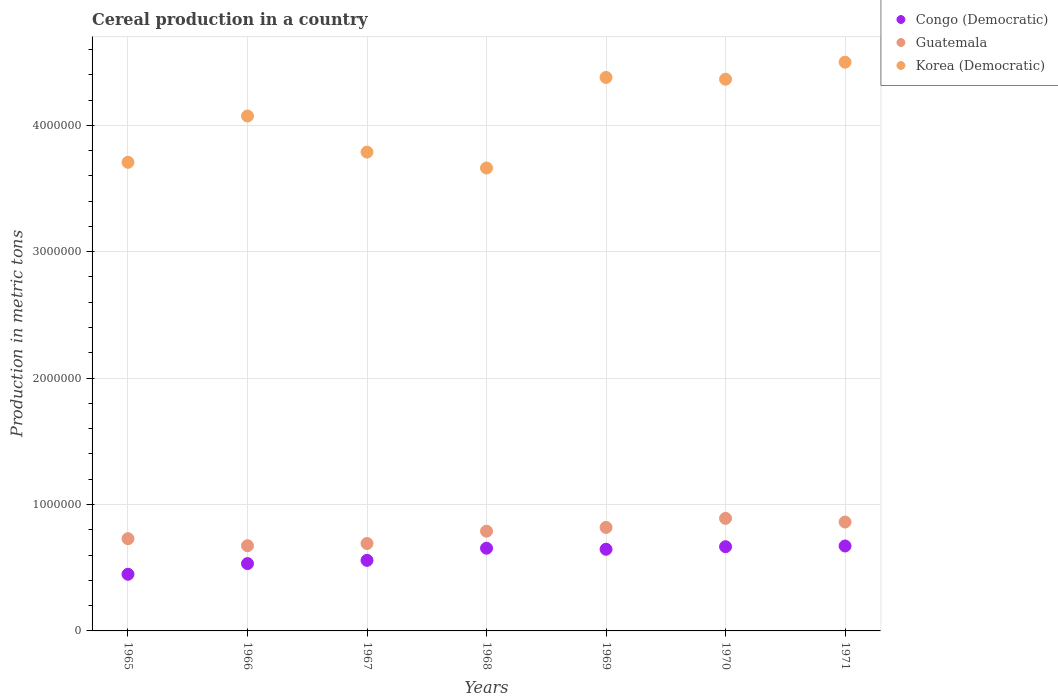How many different coloured dotlines are there?
Your response must be concise. 3. Is the number of dotlines equal to the number of legend labels?
Give a very brief answer. Yes. What is the total cereal production in Guatemala in 1967?
Provide a succinct answer. 6.92e+05. Across all years, what is the maximum total cereal production in Congo (Democratic)?
Provide a short and direct response. 6.72e+05. Across all years, what is the minimum total cereal production in Congo (Democratic)?
Provide a succinct answer. 4.48e+05. In which year was the total cereal production in Korea (Democratic) minimum?
Your answer should be very brief. 1968. What is the total total cereal production in Guatemala in the graph?
Provide a short and direct response. 5.46e+06. What is the difference between the total cereal production in Guatemala in 1965 and that in 1969?
Provide a succinct answer. -8.91e+04. What is the difference between the total cereal production in Guatemala in 1968 and the total cereal production in Congo (Democratic) in 1965?
Give a very brief answer. 3.41e+05. What is the average total cereal production in Korea (Democratic) per year?
Keep it short and to the point. 4.07e+06. In the year 1971, what is the difference between the total cereal production in Korea (Democratic) and total cereal production in Congo (Democratic)?
Your answer should be very brief. 3.83e+06. In how many years, is the total cereal production in Congo (Democratic) greater than 200000 metric tons?
Ensure brevity in your answer.  7. What is the ratio of the total cereal production in Guatemala in 1969 to that in 1970?
Provide a succinct answer. 0.92. What is the difference between the highest and the second highest total cereal production in Congo (Democratic)?
Your answer should be compact. 5769. What is the difference between the highest and the lowest total cereal production in Congo (Democratic)?
Your answer should be very brief. 2.24e+05. In how many years, is the total cereal production in Guatemala greater than the average total cereal production in Guatemala taken over all years?
Provide a short and direct response. 4. Is the sum of the total cereal production in Guatemala in 1967 and 1970 greater than the maximum total cereal production in Korea (Democratic) across all years?
Keep it short and to the point. No. Is the total cereal production in Korea (Democratic) strictly greater than the total cereal production in Guatemala over the years?
Your response must be concise. Yes. How many years are there in the graph?
Ensure brevity in your answer.  7. What is the difference between two consecutive major ticks on the Y-axis?
Provide a succinct answer. 1.00e+06. Does the graph contain any zero values?
Offer a terse response. No. Does the graph contain grids?
Make the answer very short. Yes. What is the title of the graph?
Give a very brief answer. Cereal production in a country. Does "Nepal" appear as one of the legend labels in the graph?
Your answer should be very brief. No. What is the label or title of the Y-axis?
Make the answer very short. Production in metric tons. What is the Production in metric tons of Congo (Democratic) in 1965?
Make the answer very short. 4.48e+05. What is the Production in metric tons of Guatemala in 1965?
Offer a terse response. 7.30e+05. What is the Production in metric tons of Korea (Democratic) in 1965?
Provide a short and direct response. 3.71e+06. What is the Production in metric tons in Congo (Democratic) in 1966?
Provide a succinct answer. 5.33e+05. What is the Production in metric tons in Guatemala in 1966?
Your answer should be compact. 6.74e+05. What is the Production in metric tons of Korea (Democratic) in 1966?
Give a very brief answer. 4.07e+06. What is the Production in metric tons of Congo (Democratic) in 1967?
Your answer should be very brief. 5.58e+05. What is the Production in metric tons in Guatemala in 1967?
Your answer should be compact. 6.92e+05. What is the Production in metric tons in Korea (Democratic) in 1967?
Offer a terse response. 3.79e+06. What is the Production in metric tons in Congo (Democratic) in 1968?
Your answer should be very brief. 6.54e+05. What is the Production in metric tons in Guatemala in 1968?
Provide a short and direct response. 7.89e+05. What is the Production in metric tons of Korea (Democratic) in 1968?
Offer a terse response. 3.66e+06. What is the Production in metric tons in Congo (Democratic) in 1969?
Your response must be concise. 6.46e+05. What is the Production in metric tons in Guatemala in 1969?
Your answer should be very brief. 8.19e+05. What is the Production in metric tons in Korea (Democratic) in 1969?
Offer a very short reply. 4.38e+06. What is the Production in metric tons of Congo (Democratic) in 1970?
Offer a terse response. 6.66e+05. What is the Production in metric tons in Guatemala in 1970?
Provide a short and direct response. 8.90e+05. What is the Production in metric tons in Korea (Democratic) in 1970?
Provide a short and direct response. 4.36e+06. What is the Production in metric tons of Congo (Democratic) in 1971?
Give a very brief answer. 6.72e+05. What is the Production in metric tons in Guatemala in 1971?
Provide a succinct answer. 8.61e+05. What is the Production in metric tons in Korea (Democratic) in 1971?
Provide a succinct answer. 4.50e+06. Across all years, what is the maximum Production in metric tons in Congo (Democratic)?
Provide a short and direct response. 6.72e+05. Across all years, what is the maximum Production in metric tons in Guatemala?
Your answer should be compact. 8.90e+05. Across all years, what is the maximum Production in metric tons of Korea (Democratic)?
Provide a short and direct response. 4.50e+06. Across all years, what is the minimum Production in metric tons in Congo (Democratic)?
Provide a succinct answer. 4.48e+05. Across all years, what is the minimum Production in metric tons of Guatemala?
Offer a very short reply. 6.74e+05. Across all years, what is the minimum Production in metric tons of Korea (Democratic)?
Offer a terse response. 3.66e+06. What is the total Production in metric tons in Congo (Democratic) in the graph?
Provide a succinct answer. 4.18e+06. What is the total Production in metric tons in Guatemala in the graph?
Keep it short and to the point. 5.46e+06. What is the total Production in metric tons of Korea (Democratic) in the graph?
Ensure brevity in your answer.  2.85e+07. What is the difference between the Production in metric tons in Congo (Democratic) in 1965 and that in 1966?
Keep it short and to the point. -8.44e+04. What is the difference between the Production in metric tons of Guatemala in 1965 and that in 1966?
Provide a succinct answer. 5.56e+04. What is the difference between the Production in metric tons of Korea (Democratic) in 1965 and that in 1966?
Your answer should be compact. -3.66e+05. What is the difference between the Production in metric tons in Congo (Democratic) in 1965 and that in 1967?
Provide a succinct answer. -1.10e+05. What is the difference between the Production in metric tons in Guatemala in 1965 and that in 1967?
Offer a terse response. 3.80e+04. What is the difference between the Production in metric tons of Korea (Democratic) in 1965 and that in 1967?
Ensure brevity in your answer.  -8.08e+04. What is the difference between the Production in metric tons of Congo (Democratic) in 1965 and that in 1968?
Keep it short and to the point. -2.06e+05. What is the difference between the Production in metric tons of Guatemala in 1965 and that in 1968?
Give a very brief answer. -5.94e+04. What is the difference between the Production in metric tons in Korea (Democratic) in 1965 and that in 1968?
Your answer should be very brief. 4.50e+04. What is the difference between the Production in metric tons of Congo (Democratic) in 1965 and that in 1969?
Offer a terse response. -1.98e+05. What is the difference between the Production in metric tons in Guatemala in 1965 and that in 1969?
Give a very brief answer. -8.91e+04. What is the difference between the Production in metric tons in Korea (Democratic) in 1965 and that in 1969?
Make the answer very short. -6.71e+05. What is the difference between the Production in metric tons of Congo (Democratic) in 1965 and that in 1970?
Offer a very short reply. -2.18e+05. What is the difference between the Production in metric tons in Guatemala in 1965 and that in 1970?
Your answer should be compact. -1.61e+05. What is the difference between the Production in metric tons in Korea (Democratic) in 1965 and that in 1970?
Offer a very short reply. -6.58e+05. What is the difference between the Production in metric tons in Congo (Democratic) in 1965 and that in 1971?
Make the answer very short. -2.24e+05. What is the difference between the Production in metric tons in Guatemala in 1965 and that in 1971?
Ensure brevity in your answer.  -1.32e+05. What is the difference between the Production in metric tons of Korea (Democratic) in 1965 and that in 1971?
Your answer should be compact. -7.92e+05. What is the difference between the Production in metric tons of Congo (Democratic) in 1966 and that in 1967?
Ensure brevity in your answer.  -2.56e+04. What is the difference between the Production in metric tons in Guatemala in 1966 and that in 1967?
Make the answer very short. -1.76e+04. What is the difference between the Production in metric tons of Korea (Democratic) in 1966 and that in 1967?
Your response must be concise. 2.86e+05. What is the difference between the Production in metric tons of Congo (Democratic) in 1966 and that in 1968?
Offer a terse response. -1.22e+05. What is the difference between the Production in metric tons of Guatemala in 1966 and that in 1968?
Offer a very short reply. -1.15e+05. What is the difference between the Production in metric tons of Korea (Democratic) in 1966 and that in 1968?
Offer a terse response. 4.11e+05. What is the difference between the Production in metric tons in Congo (Democratic) in 1966 and that in 1969?
Offer a terse response. -1.13e+05. What is the difference between the Production in metric tons in Guatemala in 1966 and that in 1969?
Your response must be concise. -1.45e+05. What is the difference between the Production in metric tons of Korea (Democratic) in 1966 and that in 1969?
Make the answer very short. -3.05e+05. What is the difference between the Production in metric tons of Congo (Democratic) in 1966 and that in 1970?
Give a very brief answer. -1.34e+05. What is the difference between the Production in metric tons of Guatemala in 1966 and that in 1970?
Offer a terse response. -2.16e+05. What is the difference between the Production in metric tons in Korea (Democratic) in 1966 and that in 1970?
Provide a short and direct response. -2.91e+05. What is the difference between the Production in metric tons in Congo (Democratic) in 1966 and that in 1971?
Make the answer very short. -1.39e+05. What is the difference between the Production in metric tons in Guatemala in 1966 and that in 1971?
Provide a short and direct response. -1.87e+05. What is the difference between the Production in metric tons of Korea (Democratic) in 1966 and that in 1971?
Provide a short and direct response. -4.26e+05. What is the difference between the Production in metric tons of Congo (Democratic) in 1967 and that in 1968?
Ensure brevity in your answer.  -9.60e+04. What is the difference between the Production in metric tons of Guatemala in 1967 and that in 1968?
Offer a terse response. -9.73e+04. What is the difference between the Production in metric tons of Korea (Democratic) in 1967 and that in 1968?
Ensure brevity in your answer.  1.26e+05. What is the difference between the Production in metric tons of Congo (Democratic) in 1967 and that in 1969?
Provide a succinct answer. -8.77e+04. What is the difference between the Production in metric tons of Guatemala in 1967 and that in 1969?
Offer a terse response. -1.27e+05. What is the difference between the Production in metric tons in Korea (Democratic) in 1967 and that in 1969?
Make the answer very short. -5.91e+05. What is the difference between the Production in metric tons in Congo (Democratic) in 1967 and that in 1970?
Provide a short and direct response. -1.08e+05. What is the difference between the Production in metric tons of Guatemala in 1967 and that in 1970?
Ensure brevity in your answer.  -1.99e+05. What is the difference between the Production in metric tons in Korea (Democratic) in 1967 and that in 1970?
Offer a very short reply. -5.77e+05. What is the difference between the Production in metric tons in Congo (Democratic) in 1967 and that in 1971?
Your response must be concise. -1.14e+05. What is the difference between the Production in metric tons in Guatemala in 1967 and that in 1971?
Your answer should be compact. -1.70e+05. What is the difference between the Production in metric tons in Korea (Democratic) in 1967 and that in 1971?
Ensure brevity in your answer.  -7.11e+05. What is the difference between the Production in metric tons of Congo (Democratic) in 1968 and that in 1969?
Give a very brief answer. 8339. What is the difference between the Production in metric tons in Guatemala in 1968 and that in 1969?
Ensure brevity in your answer.  -2.97e+04. What is the difference between the Production in metric tons of Korea (Democratic) in 1968 and that in 1969?
Give a very brief answer. -7.16e+05. What is the difference between the Production in metric tons in Congo (Democratic) in 1968 and that in 1970?
Provide a succinct answer. -1.20e+04. What is the difference between the Production in metric tons in Guatemala in 1968 and that in 1970?
Offer a very short reply. -1.01e+05. What is the difference between the Production in metric tons in Korea (Democratic) in 1968 and that in 1970?
Offer a very short reply. -7.02e+05. What is the difference between the Production in metric tons in Congo (Democratic) in 1968 and that in 1971?
Offer a terse response. -1.77e+04. What is the difference between the Production in metric tons in Guatemala in 1968 and that in 1971?
Offer a very short reply. -7.24e+04. What is the difference between the Production in metric tons in Korea (Democratic) in 1968 and that in 1971?
Give a very brief answer. -8.37e+05. What is the difference between the Production in metric tons in Congo (Democratic) in 1969 and that in 1970?
Your response must be concise. -2.03e+04. What is the difference between the Production in metric tons of Guatemala in 1969 and that in 1970?
Your response must be concise. -7.16e+04. What is the difference between the Production in metric tons in Korea (Democratic) in 1969 and that in 1970?
Your answer should be compact. 1.39e+04. What is the difference between the Production in metric tons in Congo (Democratic) in 1969 and that in 1971?
Keep it short and to the point. -2.61e+04. What is the difference between the Production in metric tons of Guatemala in 1969 and that in 1971?
Ensure brevity in your answer.  -4.27e+04. What is the difference between the Production in metric tons in Korea (Democratic) in 1969 and that in 1971?
Offer a very short reply. -1.21e+05. What is the difference between the Production in metric tons in Congo (Democratic) in 1970 and that in 1971?
Keep it short and to the point. -5769. What is the difference between the Production in metric tons in Guatemala in 1970 and that in 1971?
Your answer should be compact. 2.89e+04. What is the difference between the Production in metric tons of Korea (Democratic) in 1970 and that in 1971?
Ensure brevity in your answer.  -1.35e+05. What is the difference between the Production in metric tons of Congo (Democratic) in 1965 and the Production in metric tons of Guatemala in 1966?
Provide a short and direct response. -2.26e+05. What is the difference between the Production in metric tons of Congo (Democratic) in 1965 and the Production in metric tons of Korea (Democratic) in 1966?
Keep it short and to the point. -3.63e+06. What is the difference between the Production in metric tons of Guatemala in 1965 and the Production in metric tons of Korea (Democratic) in 1966?
Provide a succinct answer. -3.34e+06. What is the difference between the Production in metric tons in Congo (Democratic) in 1965 and the Production in metric tons in Guatemala in 1967?
Provide a short and direct response. -2.43e+05. What is the difference between the Production in metric tons in Congo (Democratic) in 1965 and the Production in metric tons in Korea (Democratic) in 1967?
Give a very brief answer. -3.34e+06. What is the difference between the Production in metric tons of Guatemala in 1965 and the Production in metric tons of Korea (Democratic) in 1967?
Give a very brief answer. -3.06e+06. What is the difference between the Production in metric tons in Congo (Democratic) in 1965 and the Production in metric tons in Guatemala in 1968?
Your answer should be compact. -3.41e+05. What is the difference between the Production in metric tons of Congo (Democratic) in 1965 and the Production in metric tons of Korea (Democratic) in 1968?
Provide a short and direct response. -3.21e+06. What is the difference between the Production in metric tons of Guatemala in 1965 and the Production in metric tons of Korea (Democratic) in 1968?
Your answer should be very brief. -2.93e+06. What is the difference between the Production in metric tons in Congo (Democratic) in 1965 and the Production in metric tons in Guatemala in 1969?
Ensure brevity in your answer.  -3.71e+05. What is the difference between the Production in metric tons of Congo (Democratic) in 1965 and the Production in metric tons of Korea (Democratic) in 1969?
Ensure brevity in your answer.  -3.93e+06. What is the difference between the Production in metric tons of Guatemala in 1965 and the Production in metric tons of Korea (Democratic) in 1969?
Provide a succinct answer. -3.65e+06. What is the difference between the Production in metric tons of Congo (Democratic) in 1965 and the Production in metric tons of Guatemala in 1970?
Provide a succinct answer. -4.42e+05. What is the difference between the Production in metric tons of Congo (Democratic) in 1965 and the Production in metric tons of Korea (Democratic) in 1970?
Ensure brevity in your answer.  -3.92e+06. What is the difference between the Production in metric tons in Guatemala in 1965 and the Production in metric tons in Korea (Democratic) in 1970?
Your answer should be compact. -3.63e+06. What is the difference between the Production in metric tons in Congo (Democratic) in 1965 and the Production in metric tons in Guatemala in 1971?
Make the answer very short. -4.13e+05. What is the difference between the Production in metric tons of Congo (Democratic) in 1965 and the Production in metric tons of Korea (Democratic) in 1971?
Offer a very short reply. -4.05e+06. What is the difference between the Production in metric tons of Guatemala in 1965 and the Production in metric tons of Korea (Democratic) in 1971?
Provide a short and direct response. -3.77e+06. What is the difference between the Production in metric tons of Congo (Democratic) in 1966 and the Production in metric tons of Guatemala in 1967?
Your answer should be compact. -1.59e+05. What is the difference between the Production in metric tons in Congo (Democratic) in 1966 and the Production in metric tons in Korea (Democratic) in 1967?
Your answer should be compact. -3.26e+06. What is the difference between the Production in metric tons in Guatemala in 1966 and the Production in metric tons in Korea (Democratic) in 1967?
Make the answer very short. -3.11e+06. What is the difference between the Production in metric tons of Congo (Democratic) in 1966 and the Production in metric tons of Guatemala in 1968?
Your answer should be very brief. -2.56e+05. What is the difference between the Production in metric tons of Congo (Democratic) in 1966 and the Production in metric tons of Korea (Democratic) in 1968?
Make the answer very short. -3.13e+06. What is the difference between the Production in metric tons in Guatemala in 1966 and the Production in metric tons in Korea (Democratic) in 1968?
Your answer should be compact. -2.99e+06. What is the difference between the Production in metric tons of Congo (Democratic) in 1966 and the Production in metric tons of Guatemala in 1969?
Offer a terse response. -2.86e+05. What is the difference between the Production in metric tons in Congo (Democratic) in 1966 and the Production in metric tons in Korea (Democratic) in 1969?
Provide a succinct answer. -3.85e+06. What is the difference between the Production in metric tons in Guatemala in 1966 and the Production in metric tons in Korea (Democratic) in 1969?
Give a very brief answer. -3.70e+06. What is the difference between the Production in metric tons in Congo (Democratic) in 1966 and the Production in metric tons in Guatemala in 1970?
Provide a succinct answer. -3.58e+05. What is the difference between the Production in metric tons of Congo (Democratic) in 1966 and the Production in metric tons of Korea (Democratic) in 1970?
Provide a succinct answer. -3.83e+06. What is the difference between the Production in metric tons of Guatemala in 1966 and the Production in metric tons of Korea (Democratic) in 1970?
Provide a succinct answer. -3.69e+06. What is the difference between the Production in metric tons in Congo (Democratic) in 1966 and the Production in metric tons in Guatemala in 1971?
Offer a very short reply. -3.29e+05. What is the difference between the Production in metric tons in Congo (Democratic) in 1966 and the Production in metric tons in Korea (Democratic) in 1971?
Give a very brief answer. -3.97e+06. What is the difference between the Production in metric tons in Guatemala in 1966 and the Production in metric tons in Korea (Democratic) in 1971?
Offer a terse response. -3.83e+06. What is the difference between the Production in metric tons in Congo (Democratic) in 1967 and the Production in metric tons in Guatemala in 1968?
Offer a very short reply. -2.31e+05. What is the difference between the Production in metric tons of Congo (Democratic) in 1967 and the Production in metric tons of Korea (Democratic) in 1968?
Your answer should be very brief. -3.10e+06. What is the difference between the Production in metric tons in Guatemala in 1967 and the Production in metric tons in Korea (Democratic) in 1968?
Provide a succinct answer. -2.97e+06. What is the difference between the Production in metric tons of Congo (Democratic) in 1967 and the Production in metric tons of Guatemala in 1969?
Ensure brevity in your answer.  -2.61e+05. What is the difference between the Production in metric tons in Congo (Democratic) in 1967 and the Production in metric tons in Korea (Democratic) in 1969?
Provide a short and direct response. -3.82e+06. What is the difference between the Production in metric tons in Guatemala in 1967 and the Production in metric tons in Korea (Democratic) in 1969?
Provide a succinct answer. -3.69e+06. What is the difference between the Production in metric tons of Congo (Democratic) in 1967 and the Production in metric tons of Guatemala in 1970?
Provide a short and direct response. -3.32e+05. What is the difference between the Production in metric tons of Congo (Democratic) in 1967 and the Production in metric tons of Korea (Democratic) in 1970?
Provide a succinct answer. -3.81e+06. What is the difference between the Production in metric tons in Guatemala in 1967 and the Production in metric tons in Korea (Democratic) in 1970?
Offer a very short reply. -3.67e+06. What is the difference between the Production in metric tons in Congo (Democratic) in 1967 and the Production in metric tons in Guatemala in 1971?
Your answer should be very brief. -3.03e+05. What is the difference between the Production in metric tons of Congo (Democratic) in 1967 and the Production in metric tons of Korea (Democratic) in 1971?
Ensure brevity in your answer.  -3.94e+06. What is the difference between the Production in metric tons in Guatemala in 1967 and the Production in metric tons in Korea (Democratic) in 1971?
Give a very brief answer. -3.81e+06. What is the difference between the Production in metric tons in Congo (Democratic) in 1968 and the Production in metric tons in Guatemala in 1969?
Your response must be concise. -1.64e+05. What is the difference between the Production in metric tons in Congo (Democratic) in 1968 and the Production in metric tons in Korea (Democratic) in 1969?
Your answer should be compact. -3.72e+06. What is the difference between the Production in metric tons in Guatemala in 1968 and the Production in metric tons in Korea (Democratic) in 1969?
Your answer should be very brief. -3.59e+06. What is the difference between the Production in metric tons of Congo (Democratic) in 1968 and the Production in metric tons of Guatemala in 1970?
Ensure brevity in your answer.  -2.36e+05. What is the difference between the Production in metric tons in Congo (Democratic) in 1968 and the Production in metric tons in Korea (Democratic) in 1970?
Your response must be concise. -3.71e+06. What is the difference between the Production in metric tons of Guatemala in 1968 and the Production in metric tons of Korea (Democratic) in 1970?
Keep it short and to the point. -3.58e+06. What is the difference between the Production in metric tons of Congo (Democratic) in 1968 and the Production in metric tons of Guatemala in 1971?
Make the answer very short. -2.07e+05. What is the difference between the Production in metric tons of Congo (Democratic) in 1968 and the Production in metric tons of Korea (Democratic) in 1971?
Provide a succinct answer. -3.84e+06. What is the difference between the Production in metric tons in Guatemala in 1968 and the Production in metric tons in Korea (Democratic) in 1971?
Your answer should be very brief. -3.71e+06. What is the difference between the Production in metric tons of Congo (Democratic) in 1969 and the Production in metric tons of Guatemala in 1970?
Offer a very short reply. -2.44e+05. What is the difference between the Production in metric tons in Congo (Democratic) in 1969 and the Production in metric tons in Korea (Democratic) in 1970?
Your answer should be very brief. -3.72e+06. What is the difference between the Production in metric tons of Guatemala in 1969 and the Production in metric tons of Korea (Democratic) in 1970?
Offer a terse response. -3.55e+06. What is the difference between the Production in metric tons of Congo (Democratic) in 1969 and the Production in metric tons of Guatemala in 1971?
Ensure brevity in your answer.  -2.16e+05. What is the difference between the Production in metric tons of Congo (Democratic) in 1969 and the Production in metric tons of Korea (Democratic) in 1971?
Keep it short and to the point. -3.85e+06. What is the difference between the Production in metric tons of Guatemala in 1969 and the Production in metric tons of Korea (Democratic) in 1971?
Ensure brevity in your answer.  -3.68e+06. What is the difference between the Production in metric tons in Congo (Democratic) in 1970 and the Production in metric tons in Guatemala in 1971?
Make the answer very short. -1.95e+05. What is the difference between the Production in metric tons of Congo (Democratic) in 1970 and the Production in metric tons of Korea (Democratic) in 1971?
Your response must be concise. -3.83e+06. What is the difference between the Production in metric tons of Guatemala in 1970 and the Production in metric tons of Korea (Democratic) in 1971?
Give a very brief answer. -3.61e+06. What is the average Production in metric tons of Congo (Democratic) per year?
Offer a very short reply. 5.97e+05. What is the average Production in metric tons in Guatemala per year?
Offer a very short reply. 7.79e+05. What is the average Production in metric tons of Korea (Democratic) per year?
Ensure brevity in your answer.  4.07e+06. In the year 1965, what is the difference between the Production in metric tons in Congo (Democratic) and Production in metric tons in Guatemala?
Ensure brevity in your answer.  -2.81e+05. In the year 1965, what is the difference between the Production in metric tons of Congo (Democratic) and Production in metric tons of Korea (Democratic)?
Your answer should be very brief. -3.26e+06. In the year 1965, what is the difference between the Production in metric tons of Guatemala and Production in metric tons of Korea (Democratic)?
Make the answer very short. -2.98e+06. In the year 1966, what is the difference between the Production in metric tons in Congo (Democratic) and Production in metric tons in Guatemala?
Your answer should be very brief. -1.42e+05. In the year 1966, what is the difference between the Production in metric tons in Congo (Democratic) and Production in metric tons in Korea (Democratic)?
Offer a very short reply. -3.54e+06. In the year 1966, what is the difference between the Production in metric tons of Guatemala and Production in metric tons of Korea (Democratic)?
Offer a terse response. -3.40e+06. In the year 1967, what is the difference between the Production in metric tons in Congo (Democratic) and Production in metric tons in Guatemala?
Make the answer very short. -1.33e+05. In the year 1967, what is the difference between the Production in metric tons of Congo (Democratic) and Production in metric tons of Korea (Democratic)?
Offer a terse response. -3.23e+06. In the year 1967, what is the difference between the Production in metric tons of Guatemala and Production in metric tons of Korea (Democratic)?
Provide a succinct answer. -3.10e+06. In the year 1968, what is the difference between the Production in metric tons in Congo (Democratic) and Production in metric tons in Guatemala?
Ensure brevity in your answer.  -1.35e+05. In the year 1968, what is the difference between the Production in metric tons of Congo (Democratic) and Production in metric tons of Korea (Democratic)?
Give a very brief answer. -3.01e+06. In the year 1968, what is the difference between the Production in metric tons of Guatemala and Production in metric tons of Korea (Democratic)?
Offer a terse response. -2.87e+06. In the year 1969, what is the difference between the Production in metric tons of Congo (Democratic) and Production in metric tons of Guatemala?
Your response must be concise. -1.73e+05. In the year 1969, what is the difference between the Production in metric tons of Congo (Democratic) and Production in metric tons of Korea (Democratic)?
Provide a succinct answer. -3.73e+06. In the year 1969, what is the difference between the Production in metric tons of Guatemala and Production in metric tons of Korea (Democratic)?
Your answer should be compact. -3.56e+06. In the year 1970, what is the difference between the Production in metric tons of Congo (Democratic) and Production in metric tons of Guatemala?
Your answer should be compact. -2.24e+05. In the year 1970, what is the difference between the Production in metric tons in Congo (Democratic) and Production in metric tons in Korea (Democratic)?
Ensure brevity in your answer.  -3.70e+06. In the year 1970, what is the difference between the Production in metric tons of Guatemala and Production in metric tons of Korea (Democratic)?
Your response must be concise. -3.47e+06. In the year 1971, what is the difference between the Production in metric tons in Congo (Democratic) and Production in metric tons in Guatemala?
Ensure brevity in your answer.  -1.89e+05. In the year 1971, what is the difference between the Production in metric tons in Congo (Democratic) and Production in metric tons in Korea (Democratic)?
Offer a terse response. -3.83e+06. In the year 1971, what is the difference between the Production in metric tons of Guatemala and Production in metric tons of Korea (Democratic)?
Provide a short and direct response. -3.64e+06. What is the ratio of the Production in metric tons in Congo (Democratic) in 1965 to that in 1966?
Make the answer very short. 0.84. What is the ratio of the Production in metric tons in Guatemala in 1965 to that in 1966?
Your response must be concise. 1.08. What is the ratio of the Production in metric tons of Korea (Democratic) in 1965 to that in 1966?
Offer a very short reply. 0.91. What is the ratio of the Production in metric tons in Congo (Democratic) in 1965 to that in 1967?
Your answer should be very brief. 0.8. What is the ratio of the Production in metric tons of Guatemala in 1965 to that in 1967?
Your answer should be compact. 1.05. What is the ratio of the Production in metric tons of Korea (Democratic) in 1965 to that in 1967?
Ensure brevity in your answer.  0.98. What is the ratio of the Production in metric tons in Congo (Democratic) in 1965 to that in 1968?
Provide a succinct answer. 0.69. What is the ratio of the Production in metric tons in Guatemala in 1965 to that in 1968?
Provide a short and direct response. 0.92. What is the ratio of the Production in metric tons of Korea (Democratic) in 1965 to that in 1968?
Make the answer very short. 1.01. What is the ratio of the Production in metric tons in Congo (Democratic) in 1965 to that in 1969?
Provide a succinct answer. 0.69. What is the ratio of the Production in metric tons of Guatemala in 1965 to that in 1969?
Your response must be concise. 0.89. What is the ratio of the Production in metric tons in Korea (Democratic) in 1965 to that in 1969?
Provide a succinct answer. 0.85. What is the ratio of the Production in metric tons of Congo (Democratic) in 1965 to that in 1970?
Your response must be concise. 0.67. What is the ratio of the Production in metric tons in Guatemala in 1965 to that in 1970?
Provide a succinct answer. 0.82. What is the ratio of the Production in metric tons in Korea (Democratic) in 1965 to that in 1970?
Give a very brief answer. 0.85. What is the ratio of the Production in metric tons in Congo (Democratic) in 1965 to that in 1971?
Provide a short and direct response. 0.67. What is the ratio of the Production in metric tons in Guatemala in 1965 to that in 1971?
Your answer should be very brief. 0.85. What is the ratio of the Production in metric tons in Korea (Democratic) in 1965 to that in 1971?
Your response must be concise. 0.82. What is the ratio of the Production in metric tons of Congo (Democratic) in 1966 to that in 1967?
Keep it short and to the point. 0.95. What is the ratio of the Production in metric tons of Guatemala in 1966 to that in 1967?
Ensure brevity in your answer.  0.97. What is the ratio of the Production in metric tons in Korea (Democratic) in 1966 to that in 1967?
Ensure brevity in your answer.  1.08. What is the ratio of the Production in metric tons in Congo (Democratic) in 1966 to that in 1968?
Give a very brief answer. 0.81. What is the ratio of the Production in metric tons in Guatemala in 1966 to that in 1968?
Provide a short and direct response. 0.85. What is the ratio of the Production in metric tons of Korea (Democratic) in 1966 to that in 1968?
Ensure brevity in your answer.  1.11. What is the ratio of the Production in metric tons of Congo (Democratic) in 1966 to that in 1969?
Give a very brief answer. 0.82. What is the ratio of the Production in metric tons of Guatemala in 1966 to that in 1969?
Make the answer very short. 0.82. What is the ratio of the Production in metric tons of Korea (Democratic) in 1966 to that in 1969?
Offer a terse response. 0.93. What is the ratio of the Production in metric tons of Congo (Democratic) in 1966 to that in 1970?
Ensure brevity in your answer.  0.8. What is the ratio of the Production in metric tons in Guatemala in 1966 to that in 1970?
Offer a very short reply. 0.76. What is the ratio of the Production in metric tons in Congo (Democratic) in 1966 to that in 1971?
Ensure brevity in your answer.  0.79. What is the ratio of the Production in metric tons in Guatemala in 1966 to that in 1971?
Your answer should be compact. 0.78. What is the ratio of the Production in metric tons in Korea (Democratic) in 1966 to that in 1971?
Your response must be concise. 0.91. What is the ratio of the Production in metric tons in Congo (Democratic) in 1967 to that in 1968?
Your answer should be compact. 0.85. What is the ratio of the Production in metric tons in Guatemala in 1967 to that in 1968?
Give a very brief answer. 0.88. What is the ratio of the Production in metric tons of Korea (Democratic) in 1967 to that in 1968?
Keep it short and to the point. 1.03. What is the ratio of the Production in metric tons in Congo (Democratic) in 1967 to that in 1969?
Keep it short and to the point. 0.86. What is the ratio of the Production in metric tons of Guatemala in 1967 to that in 1969?
Your answer should be very brief. 0.84. What is the ratio of the Production in metric tons in Korea (Democratic) in 1967 to that in 1969?
Ensure brevity in your answer.  0.87. What is the ratio of the Production in metric tons in Congo (Democratic) in 1967 to that in 1970?
Give a very brief answer. 0.84. What is the ratio of the Production in metric tons of Guatemala in 1967 to that in 1970?
Offer a terse response. 0.78. What is the ratio of the Production in metric tons in Korea (Democratic) in 1967 to that in 1970?
Your answer should be very brief. 0.87. What is the ratio of the Production in metric tons of Congo (Democratic) in 1967 to that in 1971?
Provide a short and direct response. 0.83. What is the ratio of the Production in metric tons in Guatemala in 1967 to that in 1971?
Ensure brevity in your answer.  0.8. What is the ratio of the Production in metric tons of Korea (Democratic) in 1967 to that in 1971?
Offer a very short reply. 0.84. What is the ratio of the Production in metric tons of Congo (Democratic) in 1968 to that in 1969?
Your response must be concise. 1.01. What is the ratio of the Production in metric tons in Guatemala in 1968 to that in 1969?
Offer a terse response. 0.96. What is the ratio of the Production in metric tons in Korea (Democratic) in 1968 to that in 1969?
Offer a terse response. 0.84. What is the ratio of the Production in metric tons of Congo (Democratic) in 1968 to that in 1970?
Keep it short and to the point. 0.98. What is the ratio of the Production in metric tons of Guatemala in 1968 to that in 1970?
Your response must be concise. 0.89. What is the ratio of the Production in metric tons in Korea (Democratic) in 1968 to that in 1970?
Provide a short and direct response. 0.84. What is the ratio of the Production in metric tons in Congo (Democratic) in 1968 to that in 1971?
Give a very brief answer. 0.97. What is the ratio of the Production in metric tons in Guatemala in 1968 to that in 1971?
Your answer should be very brief. 0.92. What is the ratio of the Production in metric tons of Korea (Democratic) in 1968 to that in 1971?
Your answer should be compact. 0.81. What is the ratio of the Production in metric tons in Congo (Democratic) in 1969 to that in 1970?
Your answer should be compact. 0.97. What is the ratio of the Production in metric tons in Guatemala in 1969 to that in 1970?
Provide a succinct answer. 0.92. What is the ratio of the Production in metric tons in Korea (Democratic) in 1969 to that in 1970?
Keep it short and to the point. 1. What is the ratio of the Production in metric tons in Congo (Democratic) in 1969 to that in 1971?
Provide a short and direct response. 0.96. What is the ratio of the Production in metric tons in Guatemala in 1969 to that in 1971?
Give a very brief answer. 0.95. What is the ratio of the Production in metric tons of Korea (Democratic) in 1969 to that in 1971?
Offer a very short reply. 0.97. What is the ratio of the Production in metric tons in Guatemala in 1970 to that in 1971?
Your answer should be very brief. 1.03. What is the ratio of the Production in metric tons of Korea (Democratic) in 1970 to that in 1971?
Offer a very short reply. 0.97. What is the difference between the highest and the second highest Production in metric tons in Congo (Democratic)?
Provide a succinct answer. 5769. What is the difference between the highest and the second highest Production in metric tons of Guatemala?
Ensure brevity in your answer.  2.89e+04. What is the difference between the highest and the second highest Production in metric tons of Korea (Democratic)?
Offer a terse response. 1.21e+05. What is the difference between the highest and the lowest Production in metric tons in Congo (Democratic)?
Offer a very short reply. 2.24e+05. What is the difference between the highest and the lowest Production in metric tons of Guatemala?
Ensure brevity in your answer.  2.16e+05. What is the difference between the highest and the lowest Production in metric tons of Korea (Democratic)?
Make the answer very short. 8.37e+05. 